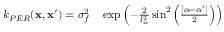<formula> <loc_0><loc_0><loc_500><loc_500>\begin{array} { r l } { k _ { P E R } ( x , x ^ { \prime } ) = \sigma _ { f } ^ { 2 } } & \exp \left ( - \frac { 2 } { l _ { \alpha } ^ { 2 } } \sin ^ { 2 } \left ( \frac { \left | \alpha - \alpha ^ { \prime } \right | } { 2 } \right ) \right ) } \end{array}</formula> 